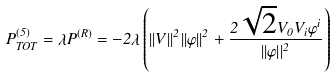<formula> <loc_0><loc_0><loc_500><loc_500>P ^ { ( 5 ) } _ { T O T } = \lambda P ^ { ( R ) } = - 2 \lambda \left ( | | V | | ^ { 2 } | | \varphi | | ^ { 2 } + \frac { 2 \sqrt { 2 } V _ { 0 } V _ { i } \varphi ^ { i } } { | | \varphi | | ^ { 2 } } \right )</formula> 